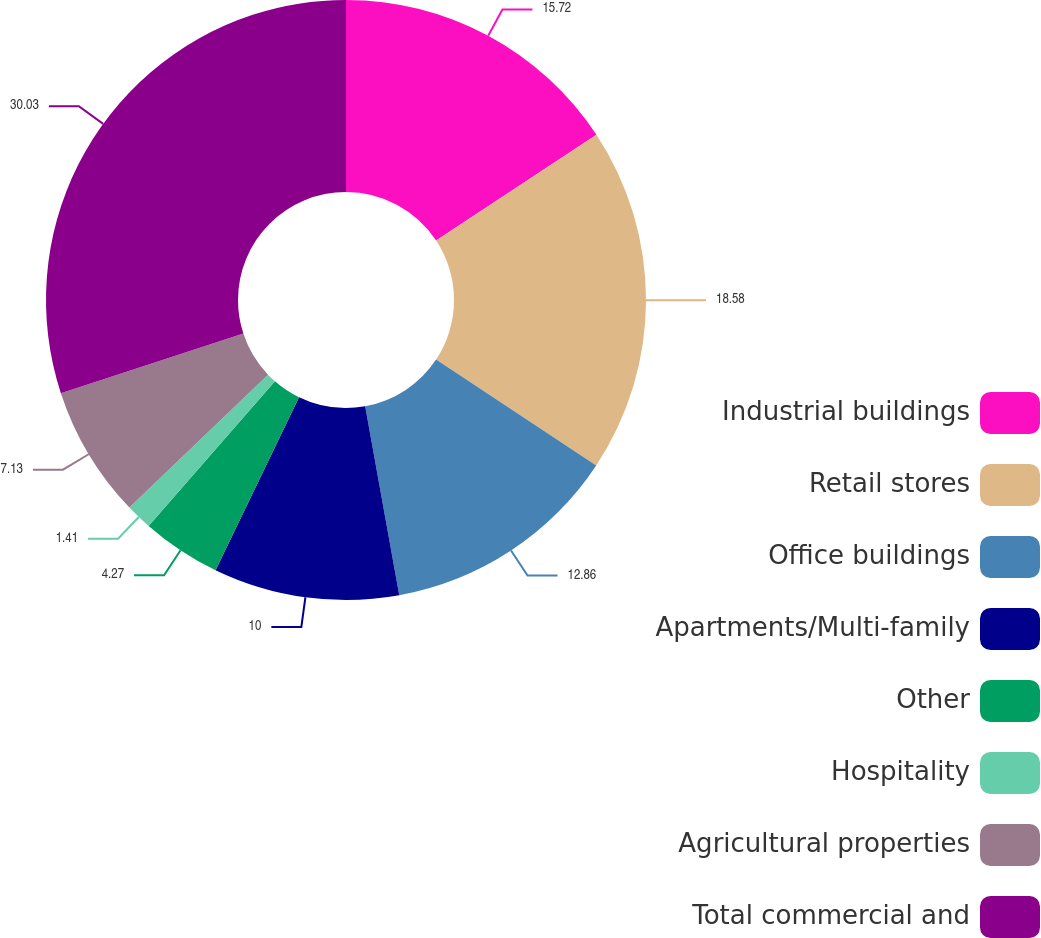<chart> <loc_0><loc_0><loc_500><loc_500><pie_chart><fcel>Industrial buildings<fcel>Retail stores<fcel>Office buildings<fcel>Apartments/Multi-family<fcel>Other<fcel>Hospitality<fcel>Agricultural properties<fcel>Total commercial and<nl><fcel>15.72%<fcel>18.58%<fcel>12.86%<fcel>10.0%<fcel>4.27%<fcel>1.41%<fcel>7.13%<fcel>30.03%<nl></chart> 